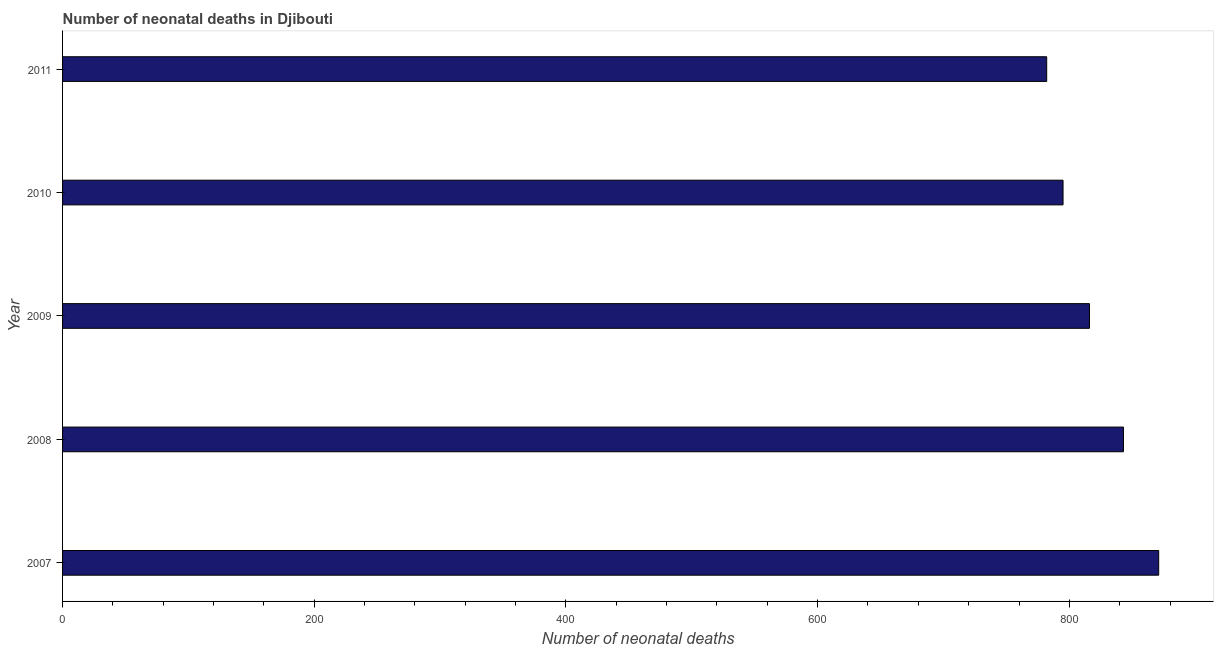Does the graph contain any zero values?
Offer a terse response. No. What is the title of the graph?
Ensure brevity in your answer.  Number of neonatal deaths in Djibouti. What is the label or title of the X-axis?
Your answer should be compact. Number of neonatal deaths. What is the label or title of the Y-axis?
Keep it short and to the point. Year. What is the number of neonatal deaths in 2007?
Keep it short and to the point. 871. Across all years, what is the maximum number of neonatal deaths?
Offer a terse response. 871. Across all years, what is the minimum number of neonatal deaths?
Provide a succinct answer. 782. In which year was the number of neonatal deaths maximum?
Offer a terse response. 2007. What is the sum of the number of neonatal deaths?
Offer a very short reply. 4107. What is the average number of neonatal deaths per year?
Keep it short and to the point. 821. What is the median number of neonatal deaths?
Keep it short and to the point. 816. In how many years, is the number of neonatal deaths greater than 480 ?
Offer a terse response. 5. What is the ratio of the number of neonatal deaths in 2007 to that in 2011?
Offer a terse response. 1.11. Is the number of neonatal deaths in 2007 less than that in 2010?
Provide a short and direct response. No. Is the sum of the number of neonatal deaths in 2008 and 2010 greater than the maximum number of neonatal deaths across all years?
Offer a very short reply. Yes. What is the difference between the highest and the lowest number of neonatal deaths?
Ensure brevity in your answer.  89. In how many years, is the number of neonatal deaths greater than the average number of neonatal deaths taken over all years?
Keep it short and to the point. 2. Are all the bars in the graph horizontal?
Keep it short and to the point. Yes. How many years are there in the graph?
Offer a very short reply. 5. What is the difference between two consecutive major ticks on the X-axis?
Provide a short and direct response. 200. Are the values on the major ticks of X-axis written in scientific E-notation?
Your answer should be very brief. No. What is the Number of neonatal deaths in 2007?
Give a very brief answer. 871. What is the Number of neonatal deaths in 2008?
Offer a very short reply. 843. What is the Number of neonatal deaths of 2009?
Offer a terse response. 816. What is the Number of neonatal deaths of 2010?
Offer a terse response. 795. What is the Number of neonatal deaths of 2011?
Give a very brief answer. 782. What is the difference between the Number of neonatal deaths in 2007 and 2010?
Keep it short and to the point. 76. What is the difference between the Number of neonatal deaths in 2007 and 2011?
Your answer should be compact. 89. What is the difference between the Number of neonatal deaths in 2008 and 2010?
Make the answer very short. 48. What is the difference between the Number of neonatal deaths in 2009 and 2010?
Offer a very short reply. 21. What is the difference between the Number of neonatal deaths in 2010 and 2011?
Your response must be concise. 13. What is the ratio of the Number of neonatal deaths in 2007 to that in 2008?
Keep it short and to the point. 1.03. What is the ratio of the Number of neonatal deaths in 2007 to that in 2009?
Give a very brief answer. 1.07. What is the ratio of the Number of neonatal deaths in 2007 to that in 2010?
Keep it short and to the point. 1.1. What is the ratio of the Number of neonatal deaths in 2007 to that in 2011?
Your answer should be compact. 1.11. What is the ratio of the Number of neonatal deaths in 2008 to that in 2009?
Make the answer very short. 1.03. What is the ratio of the Number of neonatal deaths in 2008 to that in 2010?
Your response must be concise. 1.06. What is the ratio of the Number of neonatal deaths in 2008 to that in 2011?
Your response must be concise. 1.08. What is the ratio of the Number of neonatal deaths in 2009 to that in 2011?
Keep it short and to the point. 1.04. What is the ratio of the Number of neonatal deaths in 2010 to that in 2011?
Make the answer very short. 1.02. 